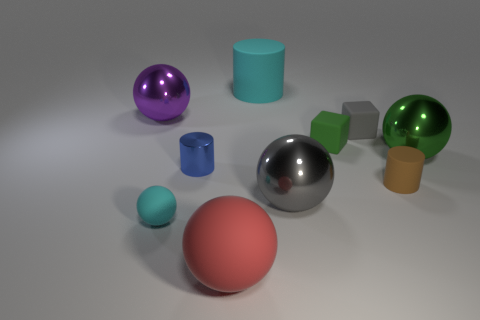What is the size of the rubber cylinder that is the same color as the tiny matte ball?
Your answer should be compact. Large. Are there any large metal spheres that have the same color as the small rubber sphere?
Your response must be concise. No. There is a rubber object that is the same size as the red ball; what is its color?
Give a very brief answer. Cyan. Is there a large cyan shiny object that has the same shape as the brown object?
Offer a very short reply. No. There is a matte object that is the same color as the large cylinder; what is its shape?
Offer a terse response. Sphere. There is a tiny blue cylinder to the left of the rubber thing that is behind the big purple thing; is there a cube in front of it?
Offer a terse response. No. There is another metallic object that is the same size as the brown thing; what is its shape?
Your response must be concise. Cylinder. The other big matte object that is the same shape as the big purple object is what color?
Your answer should be compact. Red. How many objects are small brown objects or big red objects?
Provide a short and direct response. 2. There is a metallic thing on the right side of the brown matte thing; is it the same shape as the cyan thing behind the blue metal cylinder?
Your answer should be compact. No. 